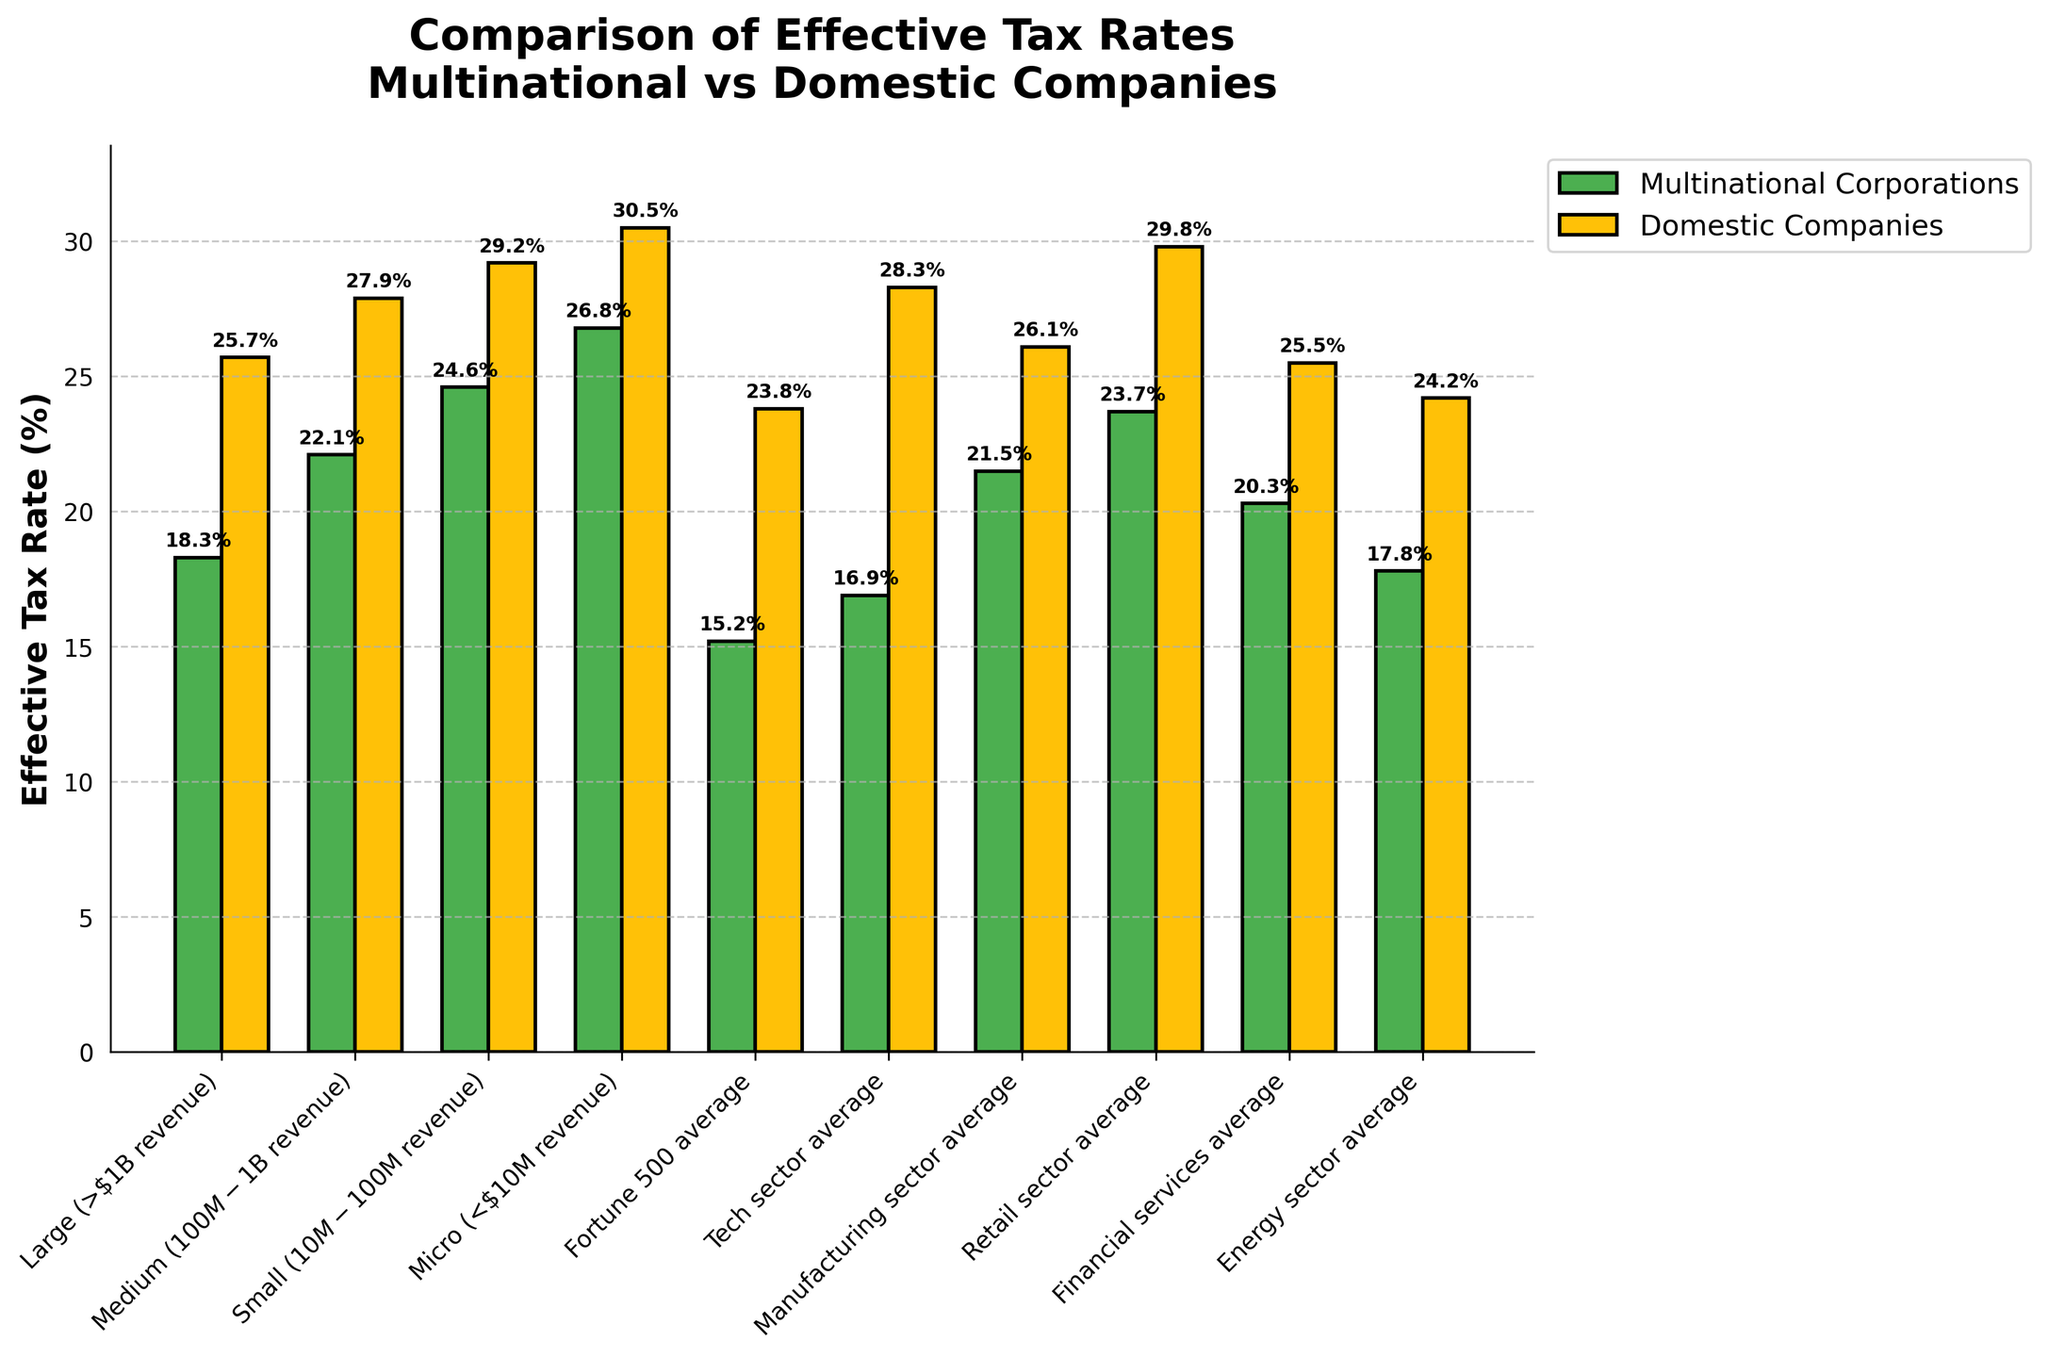What's the difference in the effective tax rate between large multinational corporations and large domestic companies? To compare the two rates, calculate the difference between the effective tax rates for large multinational corporations and large domestic companies: 25.7% - 18.3% = 7.4%.
Answer: 7.4% Which category has the lowest effective tax rate among multinational corporations? By scanning the bar heights or the numerical labels, Fortune 500 averages among multinational corporations show the lowest effective tax rate of 15.2%.
Answer: Fortune 500 average Is the effective tax rate higher for domestic companies or multinational corporations in the manufacturing sector? Compare the effective tax rates for both categories in the manufacturing sector: 26.1% for domestic companies and 21.5% for multinational corporations. Domestic companies have a higher rate.
Answer: Domestic companies What is the visual difference between the effective tax rates of the tech sector for multinational corporations and domestic companies? Observe the bar lengths and colors. The bar for domestic companies (yellow) is visibly taller than the bar for multinational corporations (green).
Answer: Domestic companies' bar is taller What’s the average effective tax rate for multinational corporations across all given sectors? First, sum the effective tax rates for multinational corporations across all sectors: 18.3 + 22.1 + 24.6 + 26.8 + 15.2 + 16.9 + 21.5 + 23.7 + 20.3 + 17.8 = 207.2. Then, divide by the number of sectors: 207.2 / 10 = 20.72%.
Answer: 20.72% How much higher is the effective tax rate for domestic companies than multinational corporations in the retail sector? Calculate the difference between the effective tax rates: 29.8% (domestic) - 23.7% (multinational) = 6.1%.
Answer: 6.1% Which size category of companies shows the smallest difference in effective tax rates between domestic and multinational corporations? Compare the differences in tax rates for each size category: 
Large: 7.4%, 
Medium: 5.8%, 
Small: 4.6%, 
Micro: 3.7%.
The smallest difference is in the Micro category (3.7%).
Answer: Micro What is the effective tax rate for multinational corporations in the energy sector? Refer to the bar representing multinational corporations in the energy sector; it is labeled 17.8%.
Answer: 17.8% Are the effective tax rates generally higher for domestic companies or multinational corporations? Compare the heights and values of the bars across all categories. Domestic companies consistently have higher effective tax rates.
Answer: Domestic companies 